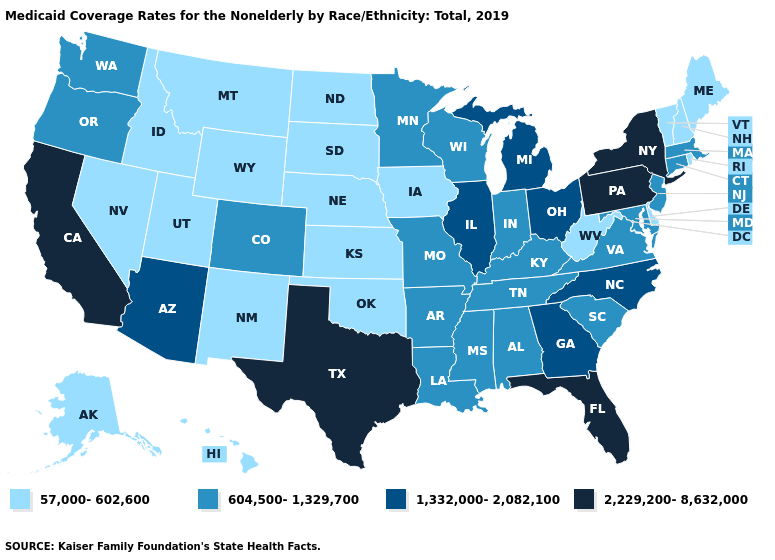Does the first symbol in the legend represent the smallest category?
Write a very short answer. Yes. What is the value of Washington?
Short answer required. 604,500-1,329,700. Name the states that have a value in the range 2,229,200-8,632,000?
Be succinct. California, Florida, New York, Pennsylvania, Texas. Does Missouri have a lower value than Delaware?
Answer briefly. No. Does Arizona have the lowest value in the USA?
Keep it brief. No. Which states hav the highest value in the MidWest?
Be succinct. Illinois, Michigan, Ohio. Does Alaska have a lower value than Montana?
Give a very brief answer. No. What is the highest value in the USA?
Concise answer only. 2,229,200-8,632,000. Name the states that have a value in the range 1,332,000-2,082,100?
Short answer required. Arizona, Georgia, Illinois, Michigan, North Carolina, Ohio. Does New Mexico have a lower value than Pennsylvania?
Short answer required. Yes. What is the highest value in the Northeast ?
Short answer required. 2,229,200-8,632,000. Does Indiana have the highest value in the MidWest?
Write a very short answer. No. Among the states that border New Hampshire , which have the highest value?
Write a very short answer. Massachusetts. What is the lowest value in the USA?
Concise answer only. 57,000-602,600. What is the value of Wisconsin?
Concise answer only. 604,500-1,329,700. 